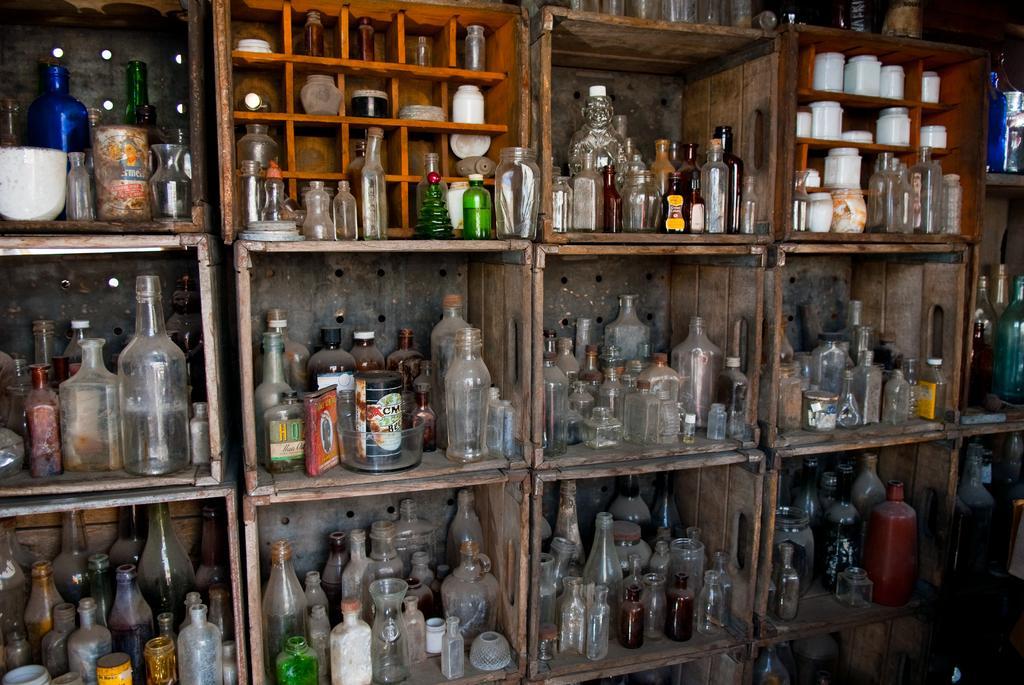Could you give a brief overview of what you see in this image? In this picture we can see some bottles in the rack. 